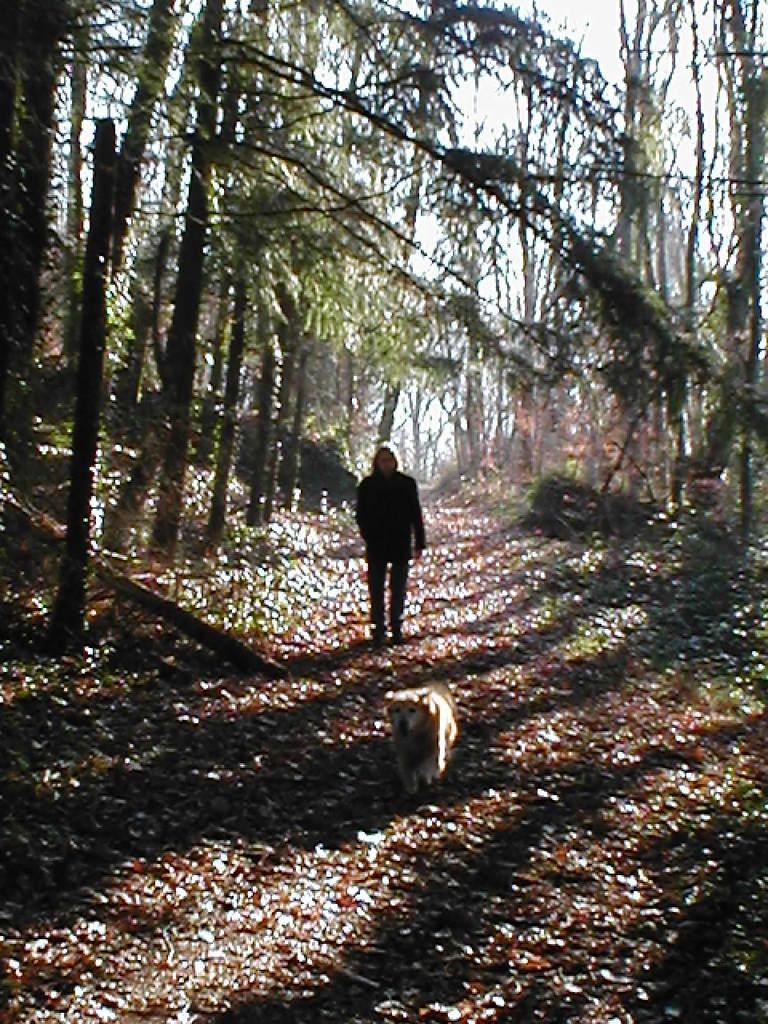In one or two sentences, can you explain what this image depicts? This image is taken outdoors. At the bottom of the image there is a ground. There are many dry leaves on the ground. In the background there are many trees with leaves, stems and branches. At the top of the image there is the sky. In the middle of the image a person and a dog are walking on the ground. 